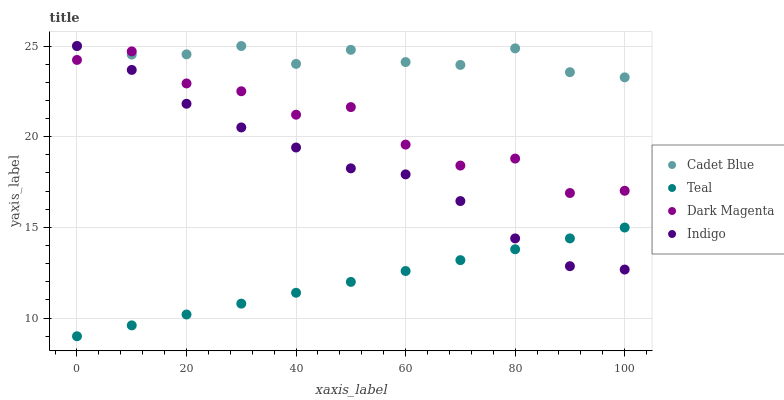Does Teal have the minimum area under the curve?
Answer yes or no. Yes. Does Cadet Blue have the maximum area under the curve?
Answer yes or no. Yes. Does Indigo have the minimum area under the curve?
Answer yes or no. No. Does Indigo have the maximum area under the curve?
Answer yes or no. No. Is Teal the smoothest?
Answer yes or no. Yes. Is Dark Magenta the roughest?
Answer yes or no. Yes. Is Indigo the smoothest?
Answer yes or no. No. Is Indigo the roughest?
Answer yes or no. No. Does Teal have the lowest value?
Answer yes or no. Yes. Does Indigo have the lowest value?
Answer yes or no. No. Does Indigo have the highest value?
Answer yes or no. Yes. Does Dark Magenta have the highest value?
Answer yes or no. No. Is Teal less than Cadet Blue?
Answer yes or no. Yes. Is Cadet Blue greater than Teal?
Answer yes or no. Yes. Does Indigo intersect Dark Magenta?
Answer yes or no. Yes. Is Indigo less than Dark Magenta?
Answer yes or no. No. Is Indigo greater than Dark Magenta?
Answer yes or no. No. Does Teal intersect Cadet Blue?
Answer yes or no. No. 